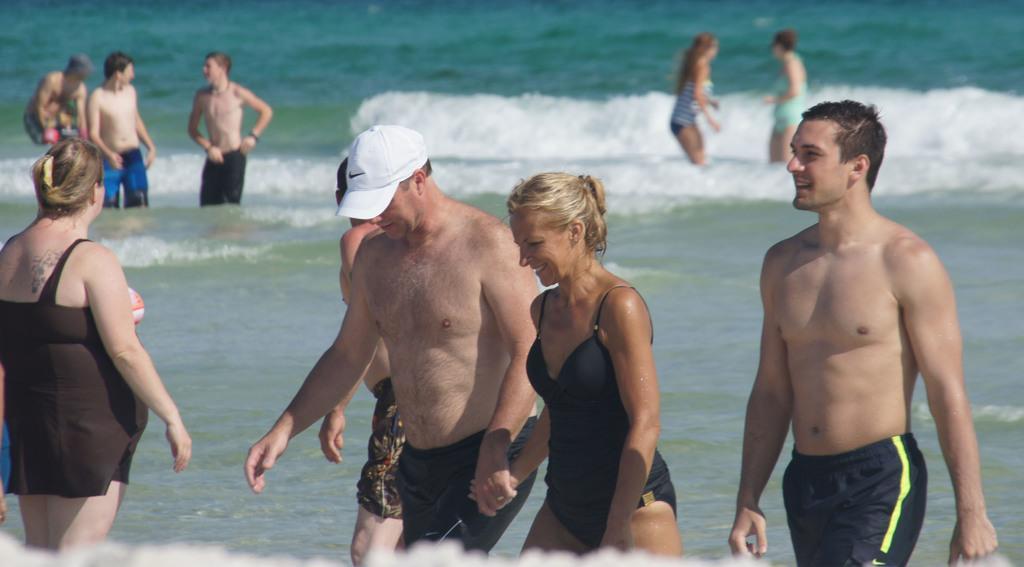How would you summarize this image in a sentence or two? In this picture we can see some people are standing in the water, there are three persons walking in the front, a man in the middle is wearing a cap, at the bottom there is water. 